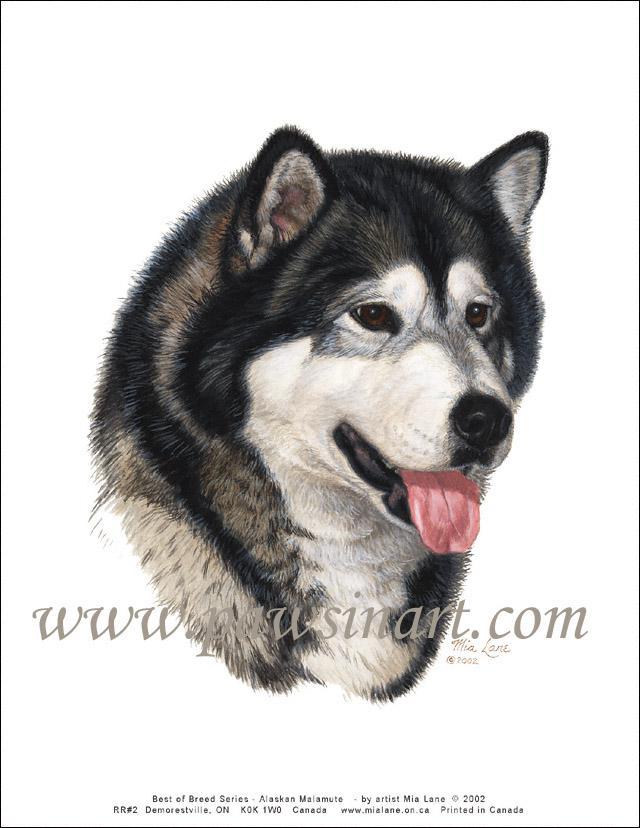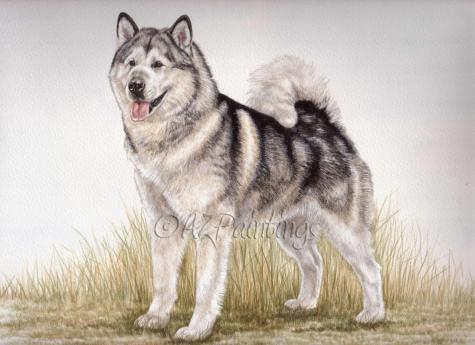The first image is the image on the left, the second image is the image on the right. For the images displayed, is the sentence "The right image features a dog with its head and body angled leftward and its tongue hanging out." factually correct? Answer yes or no. Yes. 